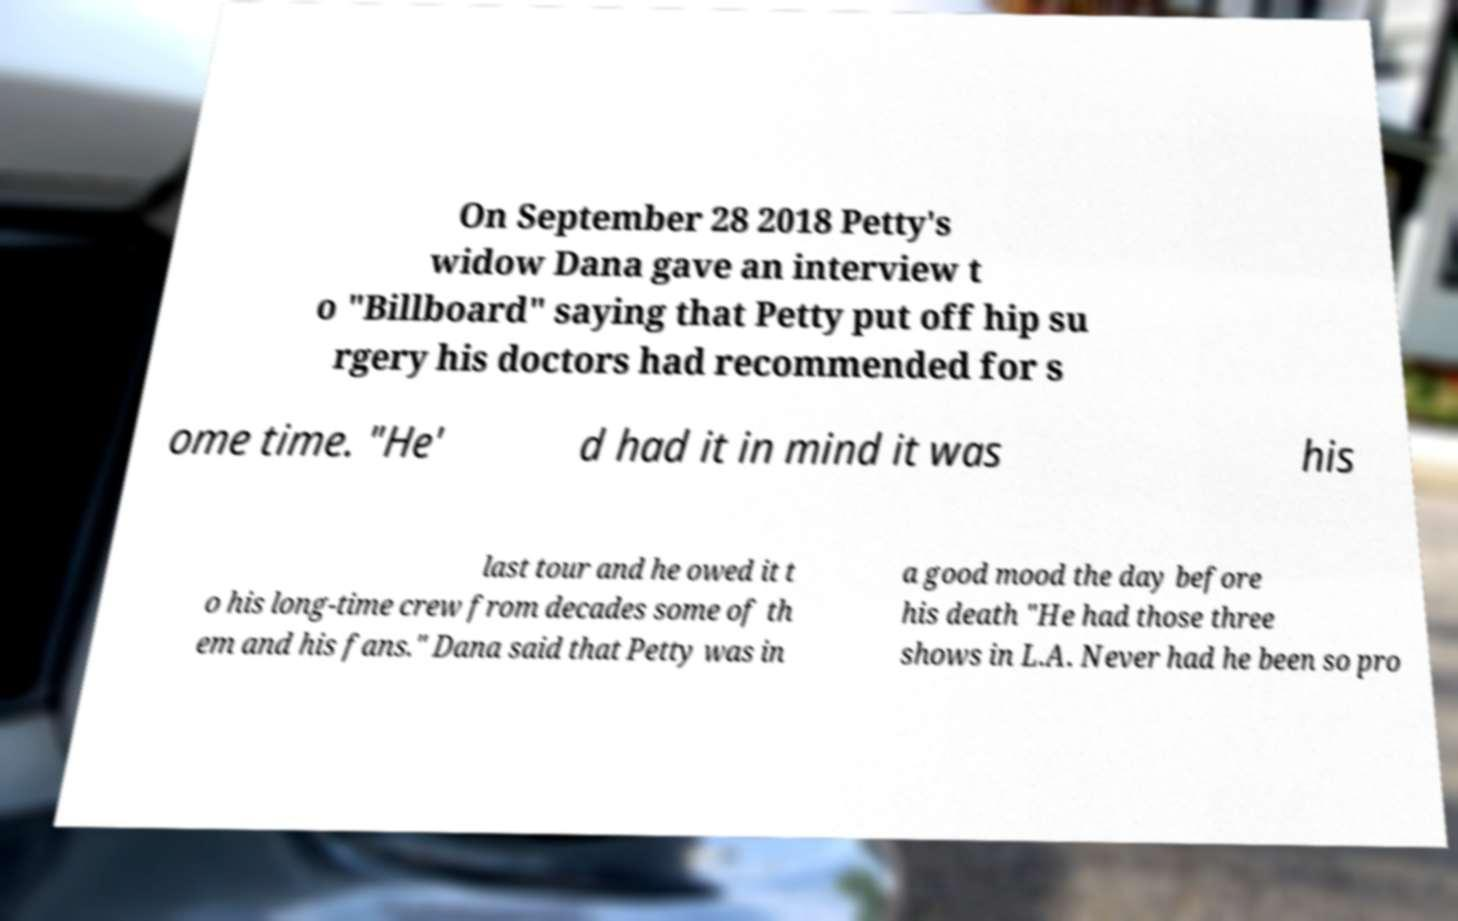Can you read and provide the text displayed in the image?This photo seems to have some interesting text. Can you extract and type it out for me? On September 28 2018 Petty's widow Dana gave an interview t o "Billboard" saying that Petty put off hip su rgery his doctors had recommended for s ome time. "He' d had it in mind it was his last tour and he owed it t o his long-time crew from decades some of th em and his fans." Dana said that Petty was in a good mood the day before his death "He had those three shows in L.A. Never had he been so pro 